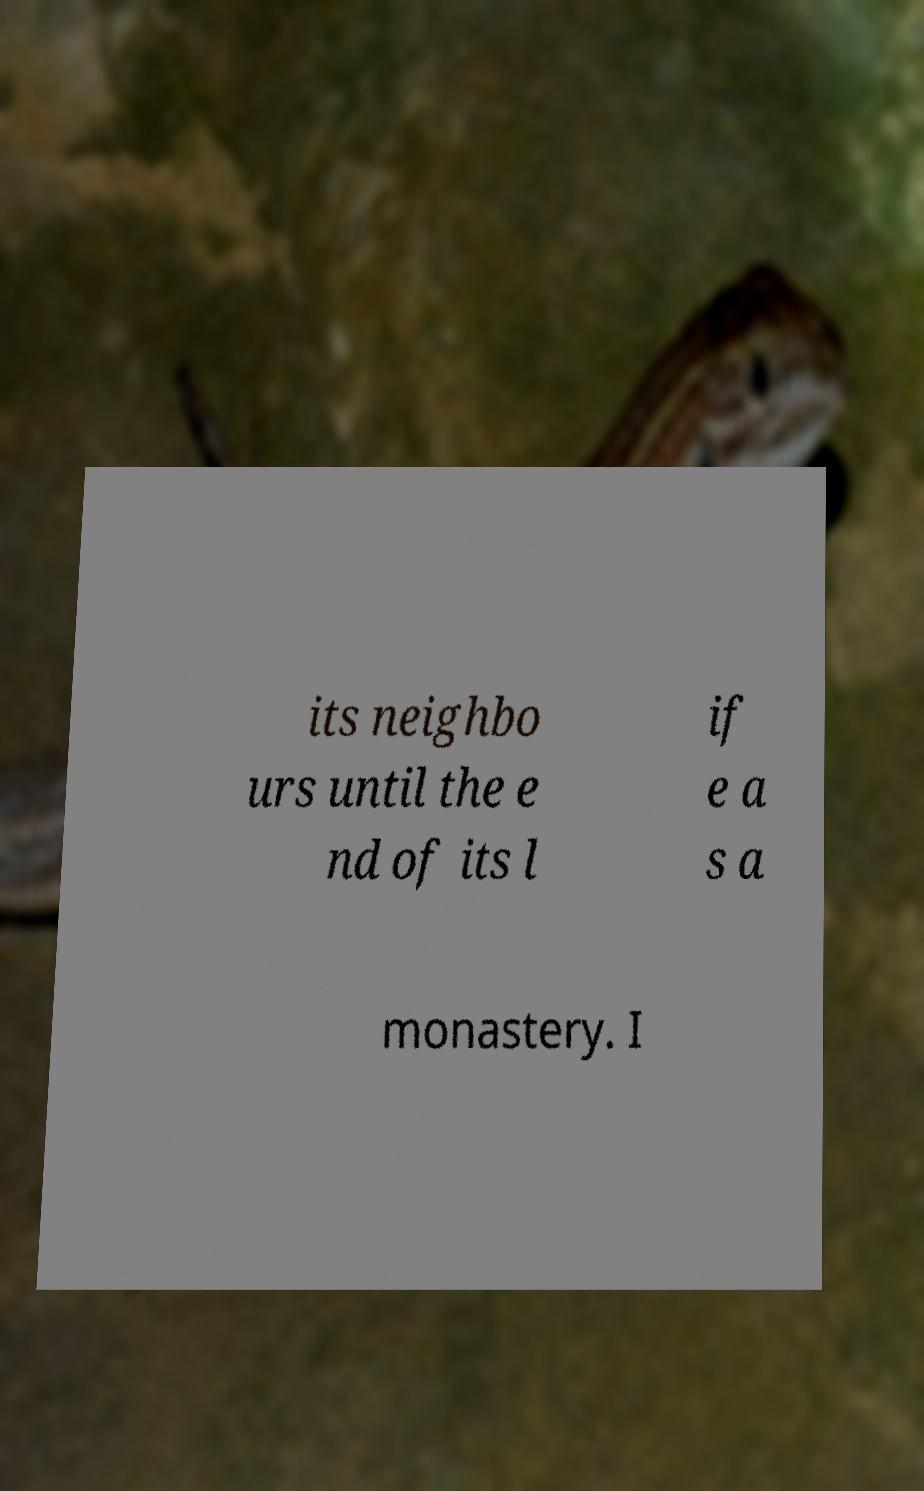Can you accurately transcribe the text from the provided image for me? its neighbo urs until the e nd of its l if e a s a monastery. I 